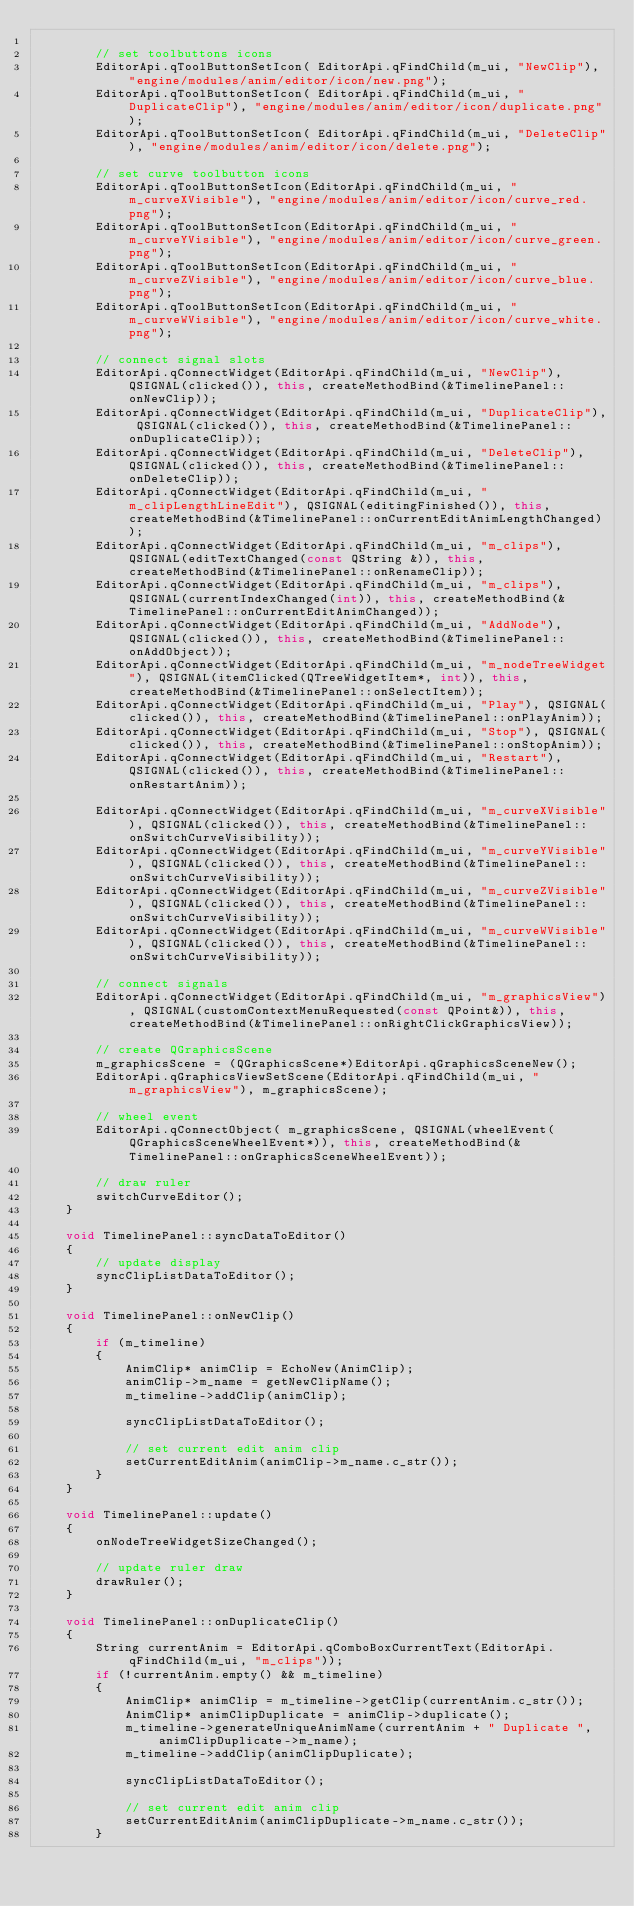<code> <loc_0><loc_0><loc_500><loc_500><_C++_>
		// set toolbuttons icons
		EditorApi.qToolButtonSetIcon( EditorApi.qFindChild(m_ui, "NewClip"), "engine/modules/anim/editor/icon/new.png");
		EditorApi.qToolButtonSetIcon( EditorApi.qFindChild(m_ui, "DuplicateClip"), "engine/modules/anim/editor/icon/duplicate.png");
		EditorApi.qToolButtonSetIcon( EditorApi.qFindChild(m_ui, "DeleteClip"), "engine/modules/anim/editor/icon/delete.png");

		// set curve toolbutton icons
		EditorApi.qToolButtonSetIcon(EditorApi.qFindChild(m_ui, "m_curveXVisible"), "engine/modules/anim/editor/icon/curve_red.png");
		EditorApi.qToolButtonSetIcon(EditorApi.qFindChild(m_ui, "m_curveYVisible"), "engine/modules/anim/editor/icon/curve_green.png");
		EditorApi.qToolButtonSetIcon(EditorApi.qFindChild(m_ui, "m_curveZVisible"), "engine/modules/anim/editor/icon/curve_blue.png");
		EditorApi.qToolButtonSetIcon(EditorApi.qFindChild(m_ui, "m_curveWVisible"), "engine/modules/anim/editor/icon/curve_white.png");

		// connect signal slots
		EditorApi.qConnectWidget(EditorApi.qFindChild(m_ui, "NewClip"), QSIGNAL(clicked()), this, createMethodBind(&TimelinePanel::onNewClip));
		EditorApi.qConnectWidget(EditorApi.qFindChild(m_ui, "DuplicateClip"), QSIGNAL(clicked()), this, createMethodBind(&TimelinePanel::onDuplicateClip));
		EditorApi.qConnectWidget(EditorApi.qFindChild(m_ui, "DeleteClip"), QSIGNAL(clicked()), this, createMethodBind(&TimelinePanel::onDeleteClip));
		EditorApi.qConnectWidget(EditorApi.qFindChild(m_ui, "m_clipLengthLineEdit"), QSIGNAL(editingFinished()), this, createMethodBind(&TimelinePanel::onCurrentEditAnimLengthChanged));
		EditorApi.qConnectWidget(EditorApi.qFindChild(m_ui, "m_clips"), QSIGNAL(editTextChanged(const QString &)), this, createMethodBind(&TimelinePanel::onRenameClip));
		EditorApi.qConnectWidget(EditorApi.qFindChild(m_ui, "m_clips"), QSIGNAL(currentIndexChanged(int)), this, createMethodBind(&TimelinePanel::onCurrentEditAnimChanged));
		EditorApi.qConnectWidget(EditorApi.qFindChild(m_ui, "AddNode"), QSIGNAL(clicked()), this, createMethodBind(&TimelinePanel::onAddObject));
		EditorApi.qConnectWidget(EditorApi.qFindChild(m_ui, "m_nodeTreeWidget"), QSIGNAL(itemClicked(QTreeWidgetItem*, int)), this, createMethodBind(&TimelinePanel::onSelectItem));
		EditorApi.qConnectWidget(EditorApi.qFindChild(m_ui, "Play"), QSIGNAL(clicked()), this, createMethodBind(&TimelinePanel::onPlayAnim));
		EditorApi.qConnectWidget(EditorApi.qFindChild(m_ui, "Stop"), QSIGNAL(clicked()), this, createMethodBind(&TimelinePanel::onStopAnim));
		EditorApi.qConnectWidget(EditorApi.qFindChild(m_ui, "Restart"), QSIGNAL(clicked()), this, createMethodBind(&TimelinePanel::onRestartAnim));

		EditorApi.qConnectWidget(EditorApi.qFindChild(m_ui, "m_curveXVisible"), QSIGNAL(clicked()), this, createMethodBind(&TimelinePanel::onSwitchCurveVisibility));
		EditorApi.qConnectWidget(EditorApi.qFindChild(m_ui, "m_curveYVisible"), QSIGNAL(clicked()), this, createMethodBind(&TimelinePanel::onSwitchCurveVisibility));
		EditorApi.qConnectWidget(EditorApi.qFindChild(m_ui, "m_curveZVisible"), QSIGNAL(clicked()), this, createMethodBind(&TimelinePanel::onSwitchCurveVisibility));
		EditorApi.qConnectWidget(EditorApi.qFindChild(m_ui, "m_curveWVisible"), QSIGNAL(clicked()), this, createMethodBind(&TimelinePanel::onSwitchCurveVisibility));

		// connect signals
		EditorApi.qConnectWidget(EditorApi.qFindChild(m_ui, "m_graphicsView"), QSIGNAL(customContextMenuRequested(const QPoint&)), this, createMethodBind(&TimelinePanel::onRightClickGraphicsView));

		// create QGraphicsScene
		m_graphicsScene = (QGraphicsScene*)EditorApi.qGraphicsSceneNew();
		EditorApi.qGraphicsViewSetScene(EditorApi.qFindChild(m_ui, "m_graphicsView"), m_graphicsScene);

		// wheel event
		EditorApi.qConnectObject( m_graphicsScene, QSIGNAL(wheelEvent(QGraphicsSceneWheelEvent*)), this, createMethodBind(&TimelinePanel::onGraphicsSceneWheelEvent));

		// draw ruler
		switchCurveEditor();
	}

	void TimelinePanel::syncDataToEditor()
	{
		// update display
		syncClipListDataToEditor();
	}

	void TimelinePanel::onNewClip()
	{
		if (m_timeline)
		{
			AnimClip* animClip = EchoNew(AnimClip);
			animClip->m_name = getNewClipName();
			m_timeline->addClip(animClip);

			syncClipListDataToEditor();

			// set current edit anim clip
			setCurrentEditAnim(animClip->m_name.c_str());
		}
	}

	void TimelinePanel::update()
	{
		onNodeTreeWidgetSizeChanged();

		// update ruler draw
		drawRuler();
	}

	void TimelinePanel::onDuplicateClip()
	{
		String currentAnim = EditorApi.qComboBoxCurrentText(EditorApi.qFindChild(m_ui, "m_clips"));
		if (!currentAnim.empty() && m_timeline)
		{
			AnimClip* animClip = m_timeline->getClip(currentAnim.c_str());
			AnimClip* animClipDuplicate = animClip->duplicate();
			m_timeline->generateUniqueAnimName(currentAnim + " Duplicate ", animClipDuplicate->m_name);
			m_timeline->addClip(animClipDuplicate);

			syncClipListDataToEditor();

			// set current edit anim clip
			setCurrentEditAnim(animClipDuplicate->m_name.c_str());
		}</code> 